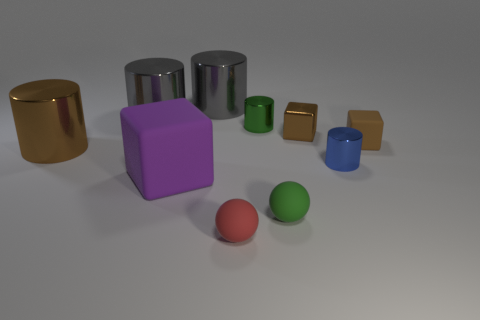What is the shape of the small rubber thing that is the same color as the small metal cube?
Keep it short and to the point. Cube. There is a green object that is behind the small blue thing; what size is it?
Give a very brief answer. Small. What is the shape of the brown metallic object that is the same size as the blue cylinder?
Offer a very short reply. Cube. Are the small green thing that is behind the large purple thing and the tiny block that is on the right side of the shiny cube made of the same material?
Your answer should be very brief. No. What material is the cylinder that is on the right side of the brown cube that is on the left side of the blue metallic cylinder?
Provide a succinct answer. Metal. There is a gray cylinder that is in front of the big gray shiny object that is right of the large gray metallic cylinder to the left of the big purple matte object; what is its size?
Provide a short and direct response. Large. Do the purple matte block and the green cylinder have the same size?
Give a very brief answer. No. Do the tiny thing that is on the right side of the tiny blue shiny object and the brown object that is left of the red object have the same shape?
Keep it short and to the point. No. Are there any tiny metallic cylinders on the left side of the small cylinder that is behind the brown cylinder?
Your answer should be very brief. No. Are there any spheres?
Keep it short and to the point. Yes. 